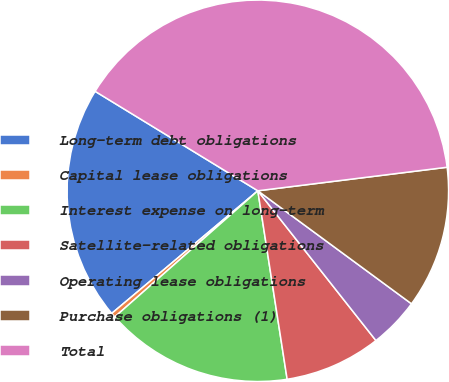Convert chart. <chart><loc_0><loc_0><loc_500><loc_500><pie_chart><fcel>Long-term debt obligations<fcel>Capital lease obligations<fcel>Interest expense on long-term<fcel>Satellite-related obligations<fcel>Operating lease obligations<fcel>Purchase obligations (1)<fcel>Total<nl><fcel>19.84%<fcel>0.39%<fcel>15.95%<fcel>8.17%<fcel>4.28%<fcel>12.06%<fcel>39.29%<nl></chart> 